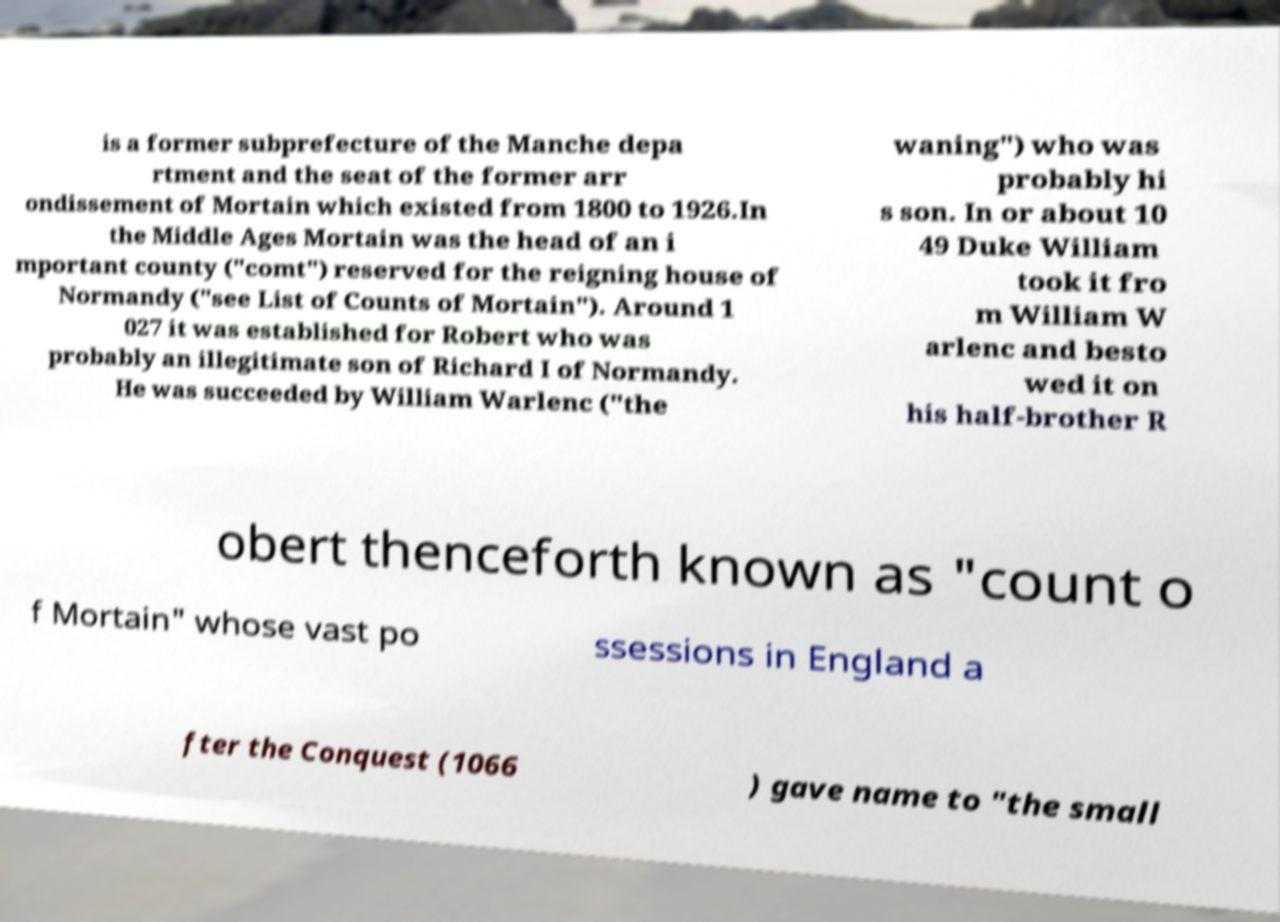Could you extract and type out the text from this image? is a former subprefecture of the Manche depa rtment and the seat of the former arr ondissement of Mortain which existed from 1800 to 1926.In the Middle Ages Mortain was the head of an i mportant county ("comt") reserved for the reigning house of Normandy ("see List of Counts of Mortain"). Around 1 027 it was established for Robert who was probably an illegitimate son of Richard I of Normandy. He was succeeded by William Warlenc ("the waning") who was probably hi s son. In or about 10 49 Duke William took it fro m William W arlenc and besto wed it on his half-brother R obert thenceforth known as "count o f Mortain" whose vast po ssessions in England a fter the Conquest (1066 ) gave name to "the small 